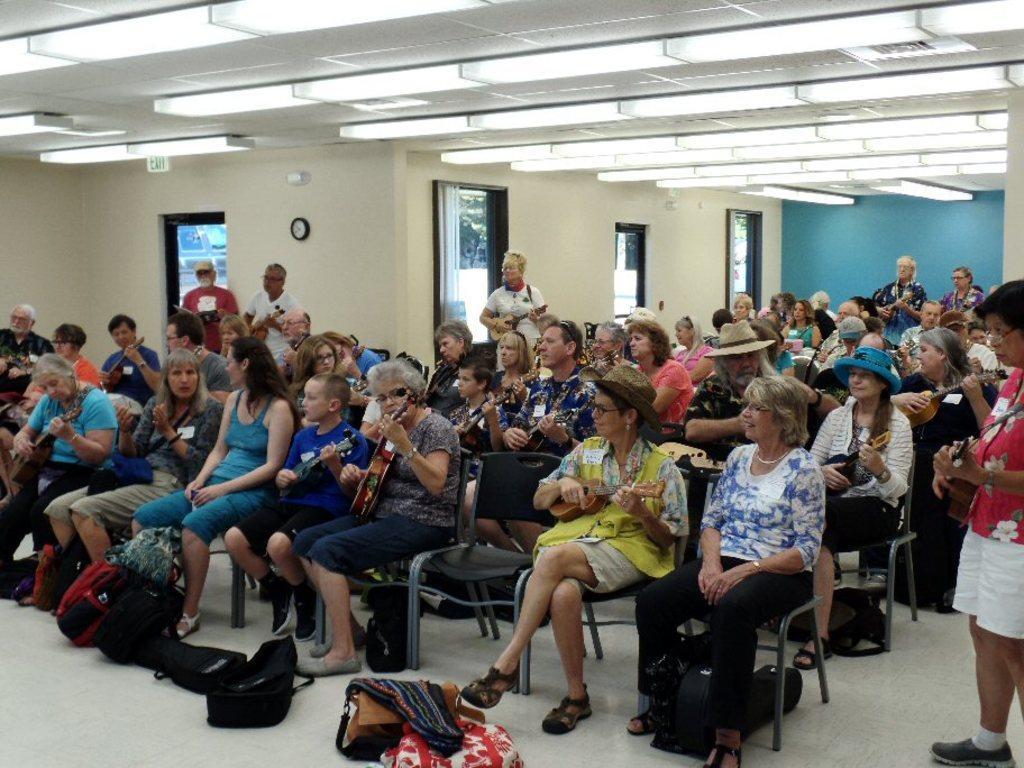Please provide a concise description of this image. In this image, there are group of people sitting on the chairs and few people standing. Among these people, I can see few people are playing the musical instruments. I can see the bags, which are kept on the floor. There are windows and a wall clock are attached to the wall. At the top of the image, there are tube lights, which are attached to the ceiling. 